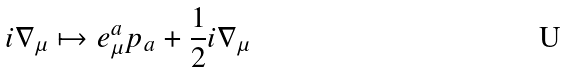Convert formula to latex. <formula><loc_0><loc_0><loc_500><loc_500>i \nabla _ { \mu } \mapsto e ^ { a } _ { \mu } p _ { a } + \frac { 1 } { 2 } i \nabla _ { \mu }</formula> 